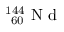<formula> <loc_0><loc_0><loc_500><loc_500>^ { 1 4 4 } _ { \ 6 0 } N d</formula> 